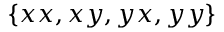Convert formula to latex. <formula><loc_0><loc_0><loc_500><loc_500>\{ x x , x y , y x , y y \}</formula> 